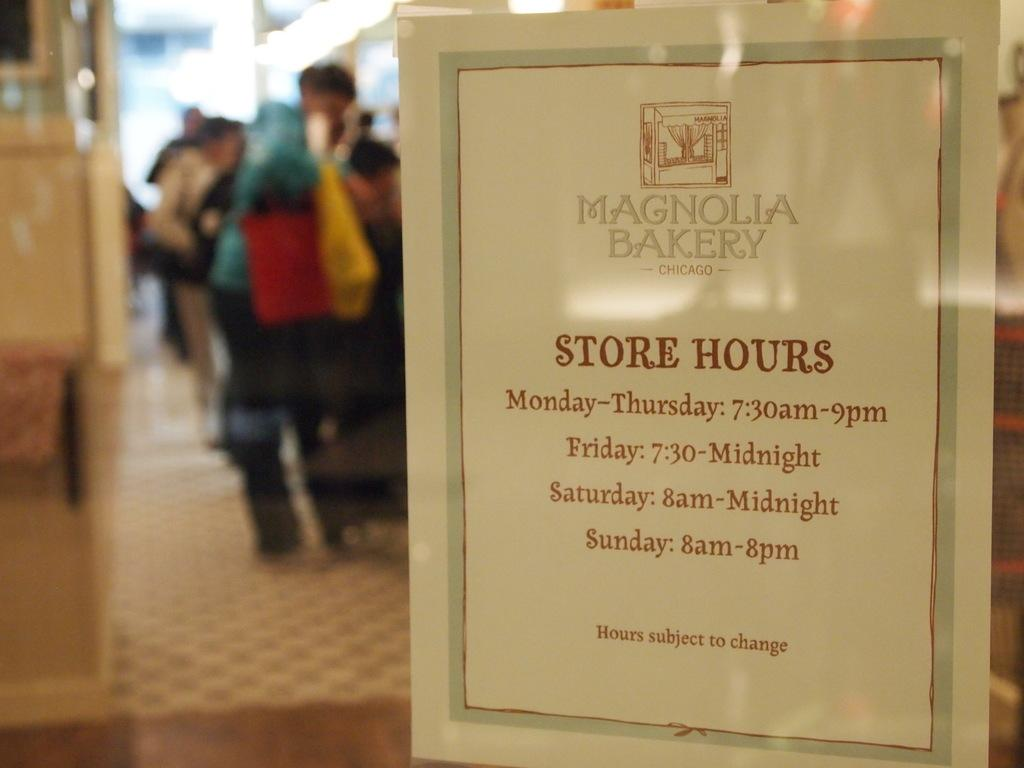<image>
Summarize the visual content of the image. A sign for the Magnolia Bakerys' Store hours from monday to sunday. 